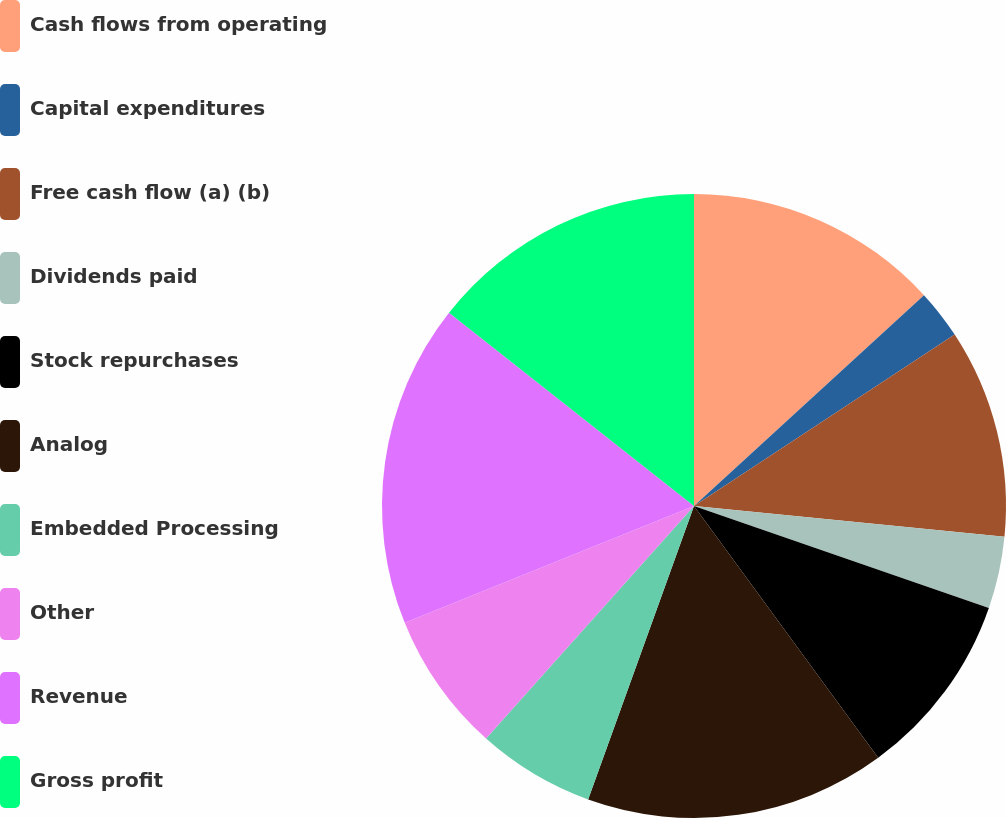Convert chart to OTSL. <chart><loc_0><loc_0><loc_500><loc_500><pie_chart><fcel>Cash flows from operating<fcel>Capital expenditures<fcel>Free cash flow (a) (b)<fcel>Dividends paid<fcel>Stock repurchases<fcel>Analog<fcel>Embedded Processing<fcel>Other<fcel>Revenue<fcel>Gross profit<nl><fcel>13.19%<fcel>2.55%<fcel>10.83%<fcel>3.73%<fcel>9.65%<fcel>15.56%<fcel>6.1%<fcel>7.28%<fcel>16.74%<fcel>14.37%<nl></chart> 